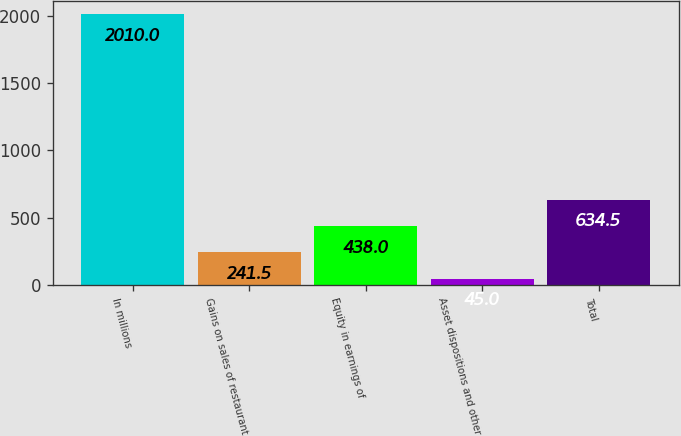<chart> <loc_0><loc_0><loc_500><loc_500><bar_chart><fcel>In millions<fcel>Gains on sales of restaurant<fcel>Equity in earnings of<fcel>Asset dispositions and other<fcel>Total<nl><fcel>2010<fcel>241.5<fcel>438<fcel>45<fcel>634.5<nl></chart> 